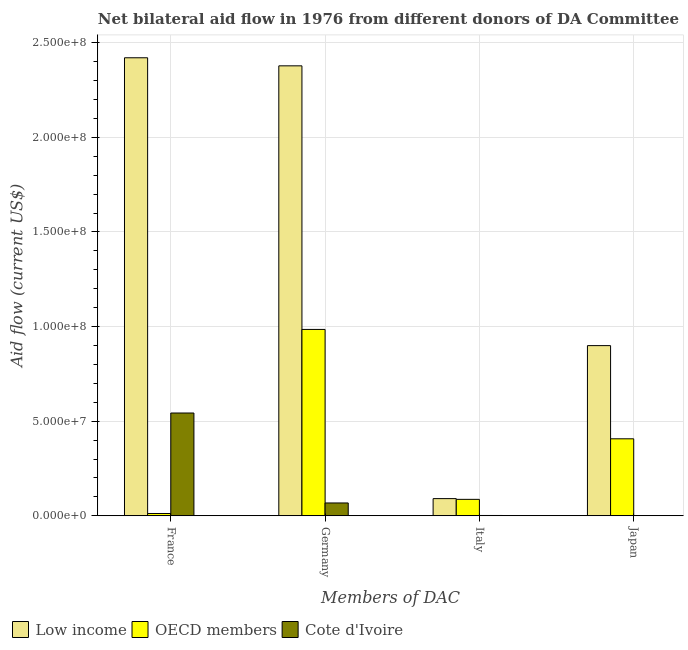Are the number of bars per tick equal to the number of legend labels?
Offer a terse response. Yes. Are the number of bars on each tick of the X-axis equal?
Offer a terse response. Yes. What is the label of the 2nd group of bars from the left?
Your response must be concise. Germany. What is the amount of aid given by france in OECD members?
Offer a very short reply. 1.20e+06. Across all countries, what is the maximum amount of aid given by france?
Keep it short and to the point. 2.42e+08. Across all countries, what is the minimum amount of aid given by japan?
Offer a very short reply. 1.50e+05. In which country was the amount of aid given by italy maximum?
Provide a succinct answer. Low income. What is the total amount of aid given by italy in the graph?
Ensure brevity in your answer.  1.79e+07. What is the difference between the amount of aid given by germany in OECD members and that in Low income?
Provide a succinct answer. -1.39e+08. What is the difference between the amount of aid given by france in OECD members and the amount of aid given by germany in Cote d'Ivoire?
Your response must be concise. -5.58e+06. What is the average amount of aid given by germany per country?
Make the answer very short. 1.14e+08. What is the difference between the amount of aid given by italy and amount of aid given by germany in OECD members?
Provide a short and direct response. -8.98e+07. What is the ratio of the amount of aid given by germany in Cote d'Ivoire to that in Low income?
Your answer should be compact. 0.03. Is the amount of aid given by italy in OECD members less than that in Low income?
Keep it short and to the point. Yes. What is the difference between the highest and the second highest amount of aid given by japan?
Offer a terse response. 4.92e+07. What is the difference between the highest and the lowest amount of aid given by japan?
Ensure brevity in your answer.  8.98e+07. In how many countries, is the amount of aid given by japan greater than the average amount of aid given by japan taken over all countries?
Your answer should be very brief. 1. Is the sum of the amount of aid given by japan in OECD members and Low income greater than the maximum amount of aid given by france across all countries?
Offer a terse response. No. What is the difference between two consecutive major ticks on the Y-axis?
Provide a short and direct response. 5.00e+07. Does the graph contain any zero values?
Provide a short and direct response. No. Does the graph contain grids?
Offer a terse response. Yes. Where does the legend appear in the graph?
Provide a succinct answer. Bottom left. What is the title of the graph?
Keep it short and to the point. Net bilateral aid flow in 1976 from different donors of DA Committee. What is the label or title of the X-axis?
Offer a terse response. Members of DAC. What is the label or title of the Y-axis?
Keep it short and to the point. Aid flow (current US$). What is the Aid flow (current US$) in Low income in France?
Keep it short and to the point. 2.42e+08. What is the Aid flow (current US$) of OECD members in France?
Your response must be concise. 1.20e+06. What is the Aid flow (current US$) of Cote d'Ivoire in France?
Your answer should be compact. 5.43e+07. What is the Aid flow (current US$) in Low income in Germany?
Keep it short and to the point. 2.38e+08. What is the Aid flow (current US$) of OECD members in Germany?
Provide a succinct answer. 9.85e+07. What is the Aid flow (current US$) of Cote d'Ivoire in Germany?
Your response must be concise. 6.78e+06. What is the Aid flow (current US$) in Low income in Italy?
Make the answer very short. 9.08e+06. What is the Aid flow (current US$) of OECD members in Italy?
Keep it short and to the point. 8.69e+06. What is the Aid flow (current US$) of Low income in Japan?
Your answer should be compact. 8.99e+07. What is the Aid flow (current US$) in OECD members in Japan?
Your response must be concise. 4.07e+07. What is the Aid flow (current US$) of Cote d'Ivoire in Japan?
Make the answer very short. 1.50e+05. Across all Members of DAC, what is the maximum Aid flow (current US$) in Low income?
Your answer should be very brief. 2.42e+08. Across all Members of DAC, what is the maximum Aid flow (current US$) in OECD members?
Offer a very short reply. 9.85e+07. Across all Members of DAC, what is the maximum Aid flow (current US$) of Cote d'Ivoire?
Your answer should be very brief. 5.43e+07. Across all Members of DAC, what is the minimum Aid flow (current US$) of Low income?
Give a very brief answer. 9.08e+06. Across all Members of DAC, what is the minimum Aid flow (current US$) in OECD members?
Your answer should be very brief. 1.20e+06. What is the total Aid flow (current US$) of Low income in the graph?
Offer a terse response. 5.79e+08. What is the total Aid flow (current US$) of OECD members in the graph?
Keep it short and to the point. 1.49e+08. What is the total Aid flow (current US$) of Cote d'Ivoire in the graph?
Give a very brief answer. 6.14e+07. What is the difference between the Aid flow (current US$) in Low income in France and that in Germany?
Offer a terse response. 4.26e+06. What is the difference between the Aid flow (current US$) of OECD members in France and that in Germany?
Your answer should be very brief. -9.73e+07. What is the difference between the Aid flow (current US$) of Cote d'Ivoire in France and that in Germany?
Make the answer very short. 4.75e+07. What is the difference between the Aid flow (current US$) of Low income in France and that in Italy?
Make the answer very short. 2.33e+08. What is the difference between the Aid flow (current US$) in OECD members in France and that in Italy?
Your answer should be very brief. -7.49e+06. What is the difference between the Aid flow (current US$) in Cote d'Ivoire in France and that in Italy?
Provide a succinct answer. 5.42e+07. What is the difference between the Aid flow (current US$) in Low income in France and that in Japan?
Offer a terse response. 1.52e+08. What is the difference between the Aid flow (current US$) in OECD members in France and that in Japan?
Give a very brief answer. -3.95e+07. What is the difference between the Aid flow (current US$) of Cote d'Ivoire in France and that in Japan?
Give a very brief answer. 5.42e+07. What is the difference between the Aid flow (current US$) in Low income in Germany and that in Italy?
Ensure brevity in your answer.  2.29e+08. What is the difference between the Aid flow (current US$) in OECD members in Germany and that in Italy?
Ensure brevity in your answer.  8.98e+07. What is the difference between the Aid flow (current US$) in Cote d'Ivoire in Germany and that in Italy?
Ensure brevity in your answer.  6.61e+06. What is the difference between the Aid flow (current US$) in Low income in Germany and that in Japan?
Your answer should be very brief. 1.48e+08. What is the difference between the Aid flow (current US$) in OECD members in Germany and that in Japan?
Ensure brevity in your answer.  5.78e+07. What is the difference between the Aid flow (current US$) in Cote d'Ivoire in Germany and that in Japan?
Provide a succinct answer. 6.63e+06. What is the difference between the Aid flow (current US$) of Low income in Italy and that in Japan?
Your answer should be very brief. -8.09e+07. What is the difference between the Aid flow (current US$) of OECD members in Italy and that in Japan?
Make the answer very short. -3.20e+07. What is the difference between the Aid flow (current US$) in Low income in France and the Aid flow (current US$) in OECD members in Germany?
Keep it short and to the point. 1.44e+08. What is the difference between the Aid flow (current US$) in Low income in France and the Aid flow (current US$) in Cote d'Ivoire in Germany?
Give a very brief answer. 2.35e+08. What is the difference between the Aid flow (current US$) in OECD members in France and the Aid flow (current US$) in Cote d'Ivoire in Germany?
Your answer should be very brief. -5.58e+06. What is the difference between the Aid flow (current US$) of Low income in France and the Aid flow (current US$) of OECD members in Italy?
Make the answer very short. 2.33e+08. What is the difference between the Aid flow (current US$) of Low income in France and the Aid flow (current US$) of Cote d'Ivoire in Italy?
Your answer should be very brief. 2.42e+08. What is the difference between the Aid flow (current US$) of OECD members in France and the Aid flow (current US$) of Cote d'Ivoire in Italy?
Your answer should be compact. 1.03e+06. What is the difference between the Aid flow (current US$) of Low income in France and the Aid flow (current US$) of OECD members in Japan?
Give a very brief answer. 2.01e+08. What is the difference between the Aid flow (current US$) in Low income in France and the Aid flow (current US$) in Cote d'Ivoire in Japan?
Offer a very short reply. 2.42e+08. What is the difference between the Aid flow (current US$) in OECD members in France and the Aid flow (current US$) in Cote d'Ivoire in Japan?
Provide a short and direct response. 1.05e+06. What is the difference between the Aid flow (current US$) of Low income in Germany and the Aid flow (current US$) of OECD members in Italy?
Your answer should be very brief. 2.29e+08. What is the difference between the Aid flow (current US$) in Low income in Germany and the Aid flow (current US$) in Cote d'Ivoire in Italy?
Give a very brief answer. 2.38e+08. What is the difference between the Aid flow (current US$) of OECD members in Germany and the Aid flow (current US$) of Cote d'Ivoire in Italy?
Your answer should be very brief. 9.83e+07. What is the difference between the Aid flow (current US$) in Low income in Germany and the Aid flow (current US$) in OECD members in Japan?
Provide a succinct answer. 1.97e+08. What is the difference between the Aid flow (current US$) in Low income in Germany and the Aid flow (current US$) in Cote d'Ivoire in Japan?
Ensure brevity in your answer.  2.38e+08. What is the difference between the Aid flow (current US$) of OECD members in Germany and the Aid flow (current US$) of Cote d'Ivoire in Japan?
Your answer should be compact. 9.83e+07. What is the difference between the Aid flow (current US$) of Low income in Italy and the Aid flow (current US$) of OECD members in Japan?
Provide a succinct answer. -3.16e+07. What is the difference between the Aid flow (current US$) of Low income in Italy and the Aid flow (current US$) of Cote d'Ivoire in Japan?
Your response must be concise. 8.93e+06. What is the difference between the Aid flow (current US$) of OECD members in Italy and the Aid flow (current US$) of Cote d'Ivoire in Japan?
Keep it short and to the point. 8.54e+06. What is the average Aid flow (current US$) of Low income per Members of DAC?
Your answer should be very brief. 1.45e+08. What is the average Aid flow (current US$) of OECD members per Members of DAC?
Keep it short and to the point. 3.73e+07. What is the average Aid flow (current US$) in Cote d'Ivoire per Members of DAC?
Your answer should be compact. 1.54e+07. What is the difference between the Aid flow (current US$) of Low income and Aid flow (current US$) of OECD members in France?
Ensure brevity in your answer.  2.41e+08. What is the difference between the Aid flow (current US$) of Low income and Aid flow (current US$) of Cote d'Ivoire in France?
Offer a terse response. 1.88e+08. What is the difference between the Aid flow (current US$) of OECD members and Aid flow (current US$) of Cote d'Ivoire in France?
Offer a very short reply. -5.31e+07. What is the difference between the Aid flow (current US$) in Low income and Aid flow (current US$) in OECD members in Germany?
Give a very brief answer. 1.39e+08. What is the difference between the Aid flow (current US$) of Low income and Aid flow (current US$) of Cote d'Ivoire in Germany?
Ensure brevity in your answer.  2.31e+08. What is the difference between the Aid flow (current US$) in OECD members and Aid flow (current US$) in Cote d'Ivoire in Germany?
Ensure brevity in your answer.  9.17e+07. What is the difference between the Aid flow (current US$) of Low income and Aid flow (current US$) of Cote d'Ivoire in Italy?
Ensure brevity in your answer.  8.91e+06. What is the difference between the Aid flow (current US$) in OECD members and Aid flow (current US$) in Cote d'Ivoire in Italy?
Provide a short and direct response. 8.52e+06. What is the difference between the Aid flow (current US$) in Low income and Aid flow (current US$) in OECD members in Japan?
Your response must be concise. 4.92e+07. What is the difference between the Aid flow (current US$) of Low income and Aid flow (current US$) of Cote d'Ivoire in Japan?
Give a very brief answer. 8.98e+07. What is the difference between the Aid flow (current US$) in OECD members and Aid flow (current US$) in Cote d'Ivoire in Japan?
Your answer should be very brief. 4.05e+07. What is the ratio of the Aid flow (current US$) of Low income in France to that in Germany?
Your answer should be compact. 1.02. What is the ratio of the Aid flow (current US$) of OECD members in France to that in Germany?
Keep it short and to the point. 0.01. What is the ratio of the Aid flow (current US$) of Cote d'Ivoire in France to that in Germany?
Your answer should be compact. 8.01. What is the ratio of the Aid flow (current US$) of Low income in France to that in Italy?
Provide a succinct answer. 26.66. What is the ratio of the Aid flow (current US$) in OECD members in France to that in Italy?
Keep it short and to the point. 0.14. What is the ratio of the Aid flow (current US$) of Cote d'Ivoire in France to that in Italy?
Provide a succinct answer. 319.53. What is the ratio of the Aid flow (current US$) in Low income in France to that in Japan?
Provide a succinct answer. 2.69. What is the ratio of the Aid flow (current US$) in OECD members in France to that in Japan?
Your answer should be very brief. 0.03. What is the ratio of the Aid flow (current US$) in Cote d'Ivoire in France to that in Japan?
Your response must be concise. 362.13. What is the ratio of the Aid flow (current US$) of Low income in Germany to that in Italy?
Give a very brief answer. 26.19. What is the ratio of the Aid flow (current US$) in OECD members in Germany to that in Italy?
Make the answer very short. 11.33. What is the ratio of the Aid flow (current US$) in Cote d'Ivoire in Germany to that in Italy?
Provide a short and direct response. 39.88. What is the ratio of the Aid flow (current US$) of Low income in Germany to that in Japan?
Provide a succinct answer. 2.64. What is the ratio of the Aid flow (current US$) in OECD members in Germany to that in Japan?
Make the answer very short. 2.42. What is the ratio of the Aid flow (current US$) in Cote d'Ivoire in Germany to that in Japan?
Provide a succinct answer. 45.2. What is the ratio of the Aid flow (current US$) of Low income in Italy to that in Japan?
Offer a very short reply. 0.1. What is the ratio of the Aid flow (current US$) in OECD members in Italy to that in Japan?
Your answer should be very brief. 0.21. What is the ratio of the Aid flow (current US$) of Cote d'Ivoire in Italy to that in Japan?
Your response must be concise. 1.13. What is the difference between the highest and the second highest Aid flow (current US$) in Low income?
Ensure brevity in your answer.  4.26e+06. What is the difference between the highest and the second highest Aid flow (current US$) of OECD members?
Offer a very short reply. 5.78e+07. What is the difference between the highest and the second highest Aid flow (current US$) in Cote d'Ivoire?
Provide a succinct answer. 4.75e+07. What is the difference between the highest and the lowest Aid flow (current US$) of Low income?
Offer a terse response. 2.33e+08. What is the difference between the highest and the lowest Aid flow (current US$) in OECD members?
Keep it short and to the point. 9.73e+07. What is the difference between the highest and the lowest Aid flow (current US$) in Cote d'Ivoire?
Offer a very short reply. 5.42e+07. 